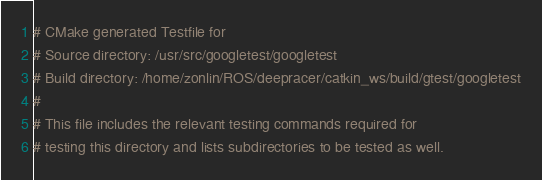Convert code to text. <code><loc_0><loc_0><loc_500><loc_500><_CMake_># CMake generated Testfile for 
# Source directory: /usr/src/googletest/googletest
# Build directory: /home/zonlin/ROS/deepracer/catkin_ws/build/gtest/googletest
# 
# This file includes the relevant testing commands required for 
# testing this directory and lists subdirectories to be tested as well.
</code> 